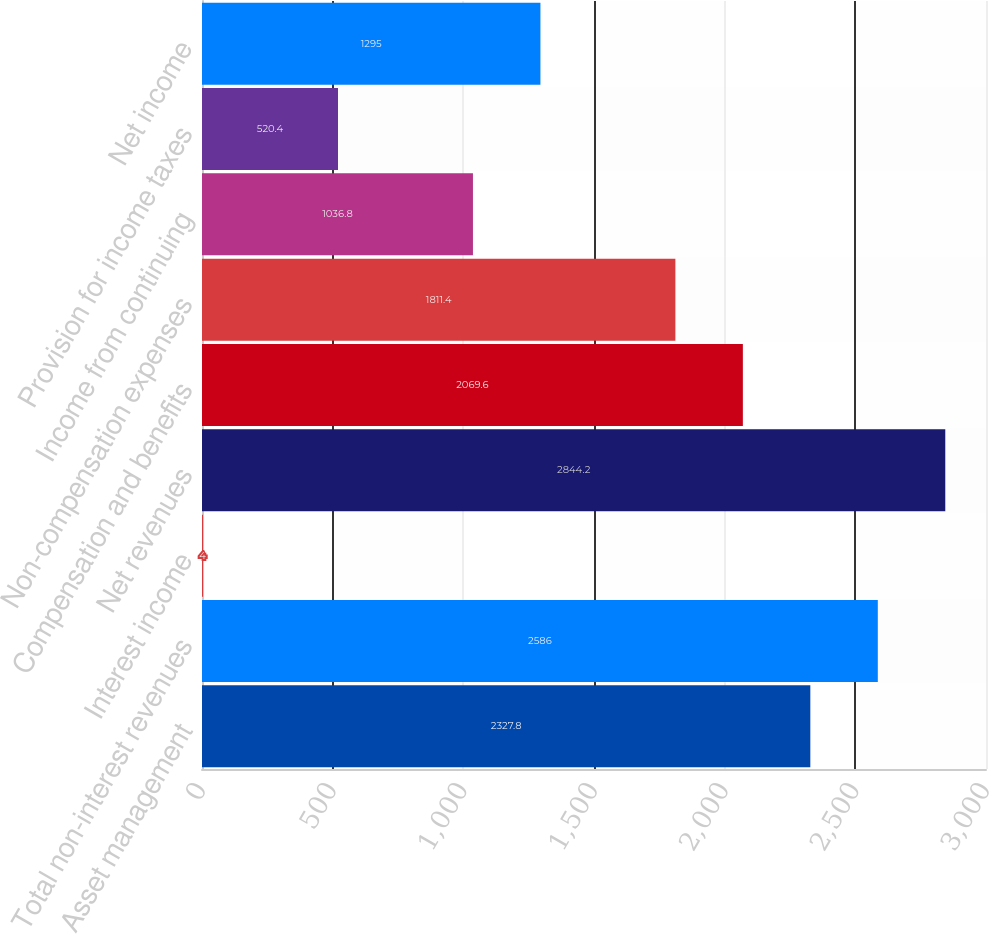<chart> <loc_0><loc_0><loc_500><loc_500><bar_chart><fcel>Asset management<fcel>Total non-interest revenues<fcel>Interest income<fcel>Net revenues<fcel>Compensation and benefits<fcel>Non-compensation expenses<fcel>Income from continuing<fcel>Provision for income taxes<fcel>Net income<nl><fcel>2327.8<fcel>2586<fcel>4<fcel>2844.2<fcel>2069.6<fcel>1811.4<fcel>1036.8<fcel>520.4<fcel>1295<nl></chart> 